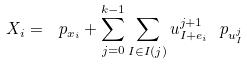Convert formula to latex. <formula><loc_0><loc_0><loc_500><loc_500>X _ { i } = \ p _ { x _ { i } } + \sum _ { j = 0 } ^ { k - 1 } \sum _ { I \in I ( j ) } u _ { I + e _ { i } } ^ { j + 1 } \ p _ { u _ { I } ^ { j } }</formula> 